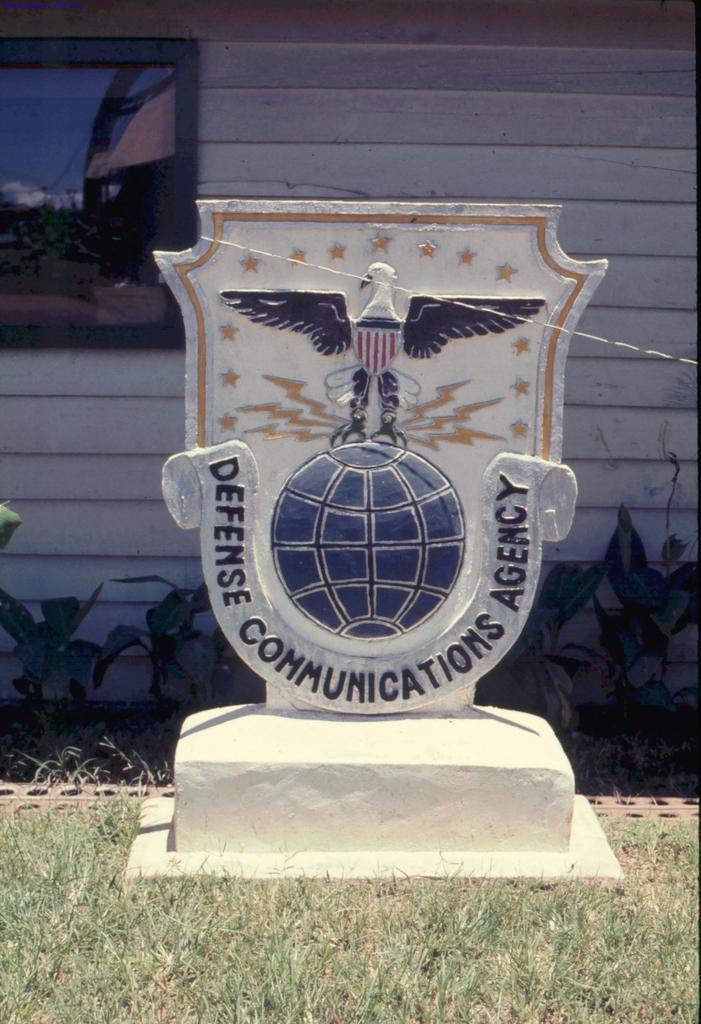How would you summarize this image in a sentence or two? In this image we can see a memorial stone. On the stone we can see some text and design. Behind the stone we can see few plants and a wall. On the left side, we can see a frame. In the frame we can see trees, house and the sky. At the bottom we can see the grass. 